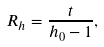<formula> <loc_0><loc_0><loc_500><loc_500>R _ { h } = \frac { t } { h _ { 0 } - 1 } ,</formula> 